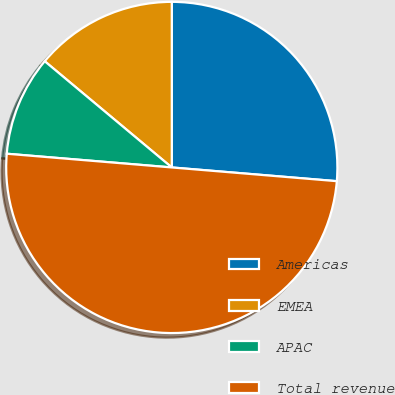Convert chart to OTSL. <chart><loc_0><loc_0><loc_500><loc_500><pie_chart><fcel>Americas<fcel>EMEA<fcel>APAC<fcel>Total revenue<nl><fcel>26.32%<fcel>13.92%<fcel>9.76%<fcel>50.0%<nl></chart> 